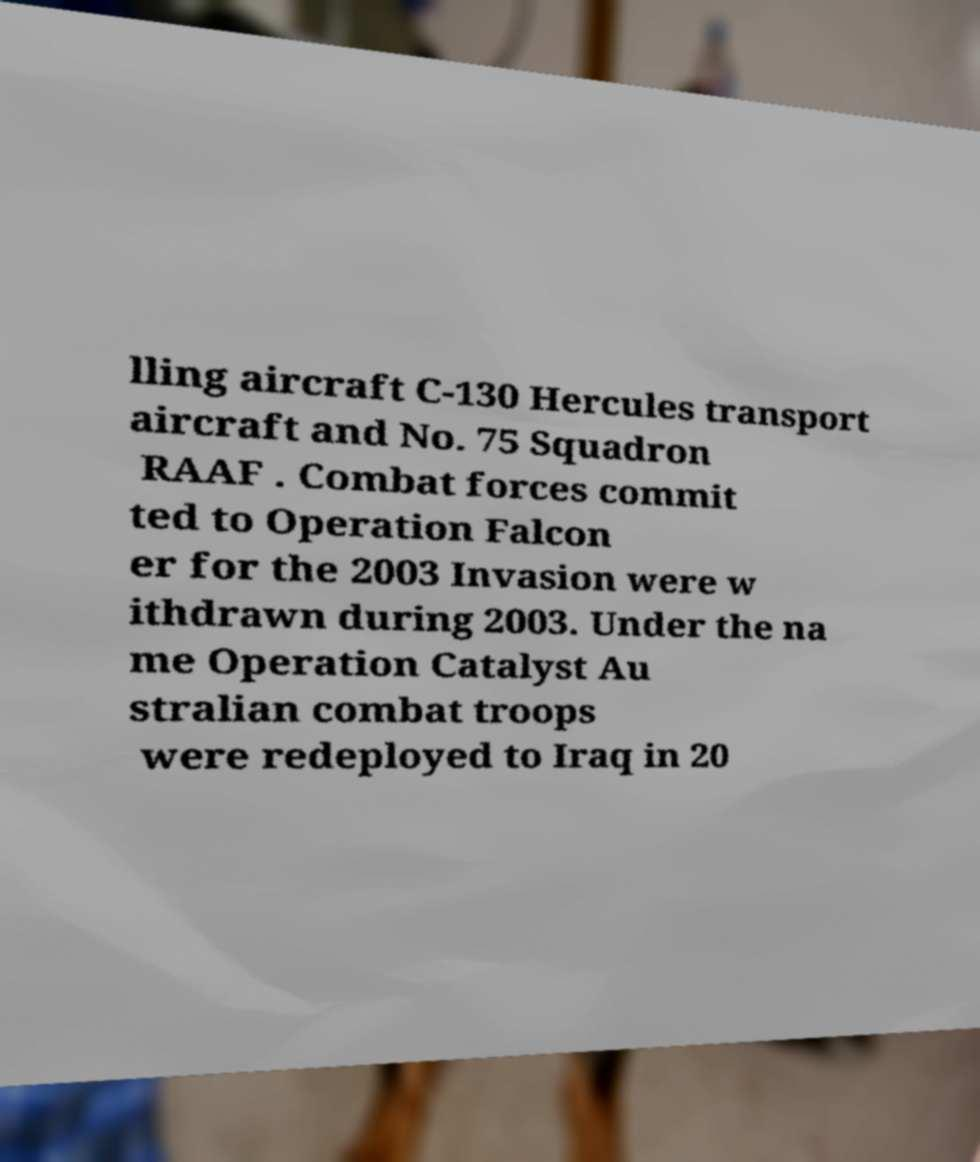There's text embedded in this image that I need extracted. Can you transcribe it verbatim? lling aircraft C-130 Hercules transport aircraft and No. 75 Squadron RAAF . Combat forces commit ted to Operation Falcon er for the 2003 Invasion were w ithdrawn during 2003. Under the na me Operation Catalyst Au stralian combat troops were redeployed to Iraq in 20 